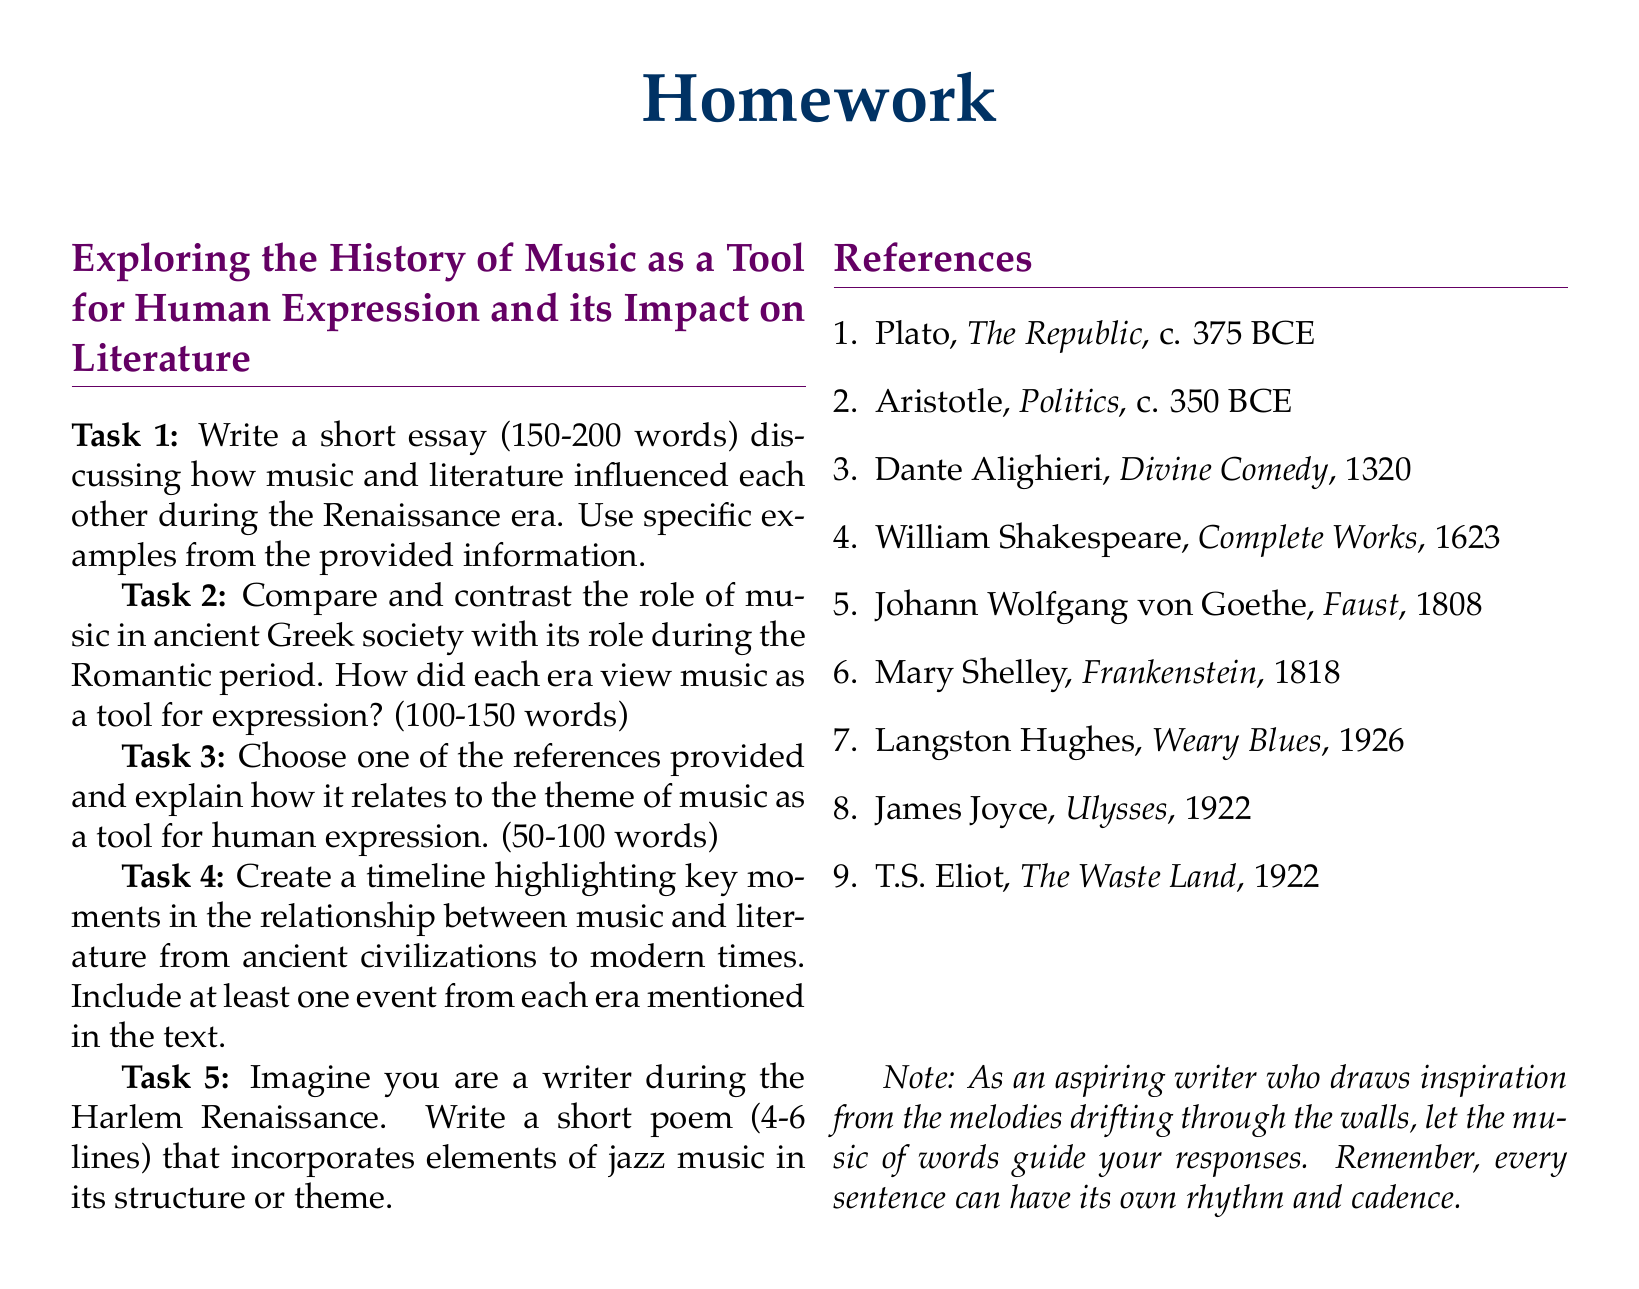What is the length requirement for Task 1? Task 1 requires a short essay of 150-200 words discussing music and literature during the Renaissance era.
Answer: 150-200 words Which literary work is associated with Dante Alighieri? Dante Alighieri is known for his work titled "Divine Comedy" from 1320.
Answer: Divine Comedy How many tasks are included in the homework document? The document includes five tasks for the homework assignment.
Answer: Five What is the theme of Task 3? Task 3 asks to explain how a chosen reference relates to the theme of music as a tool for human expression.
Answer: Theme of music as a tool for human expression Which author wrote "Frankenstein"? Mary Shelley is the author of "Frankenstein," published in 1818.
Answer: Mary Shelley What era does Task 2 compare and contrast regarding the role of music? Task 2 compares the role of music in ancient Greek society with its role during the Romantic period.
Answer: Ancient Greek society and Romantic period What is the required length for Task 2's response? Task 2 has a response length requirement of 100-150 words.
Answer: 100-150 words What poetic form does Task 5 encourage? Task 5 encourages writing a short poem that incorporates elements of jazz music.
Answer: Short poem 